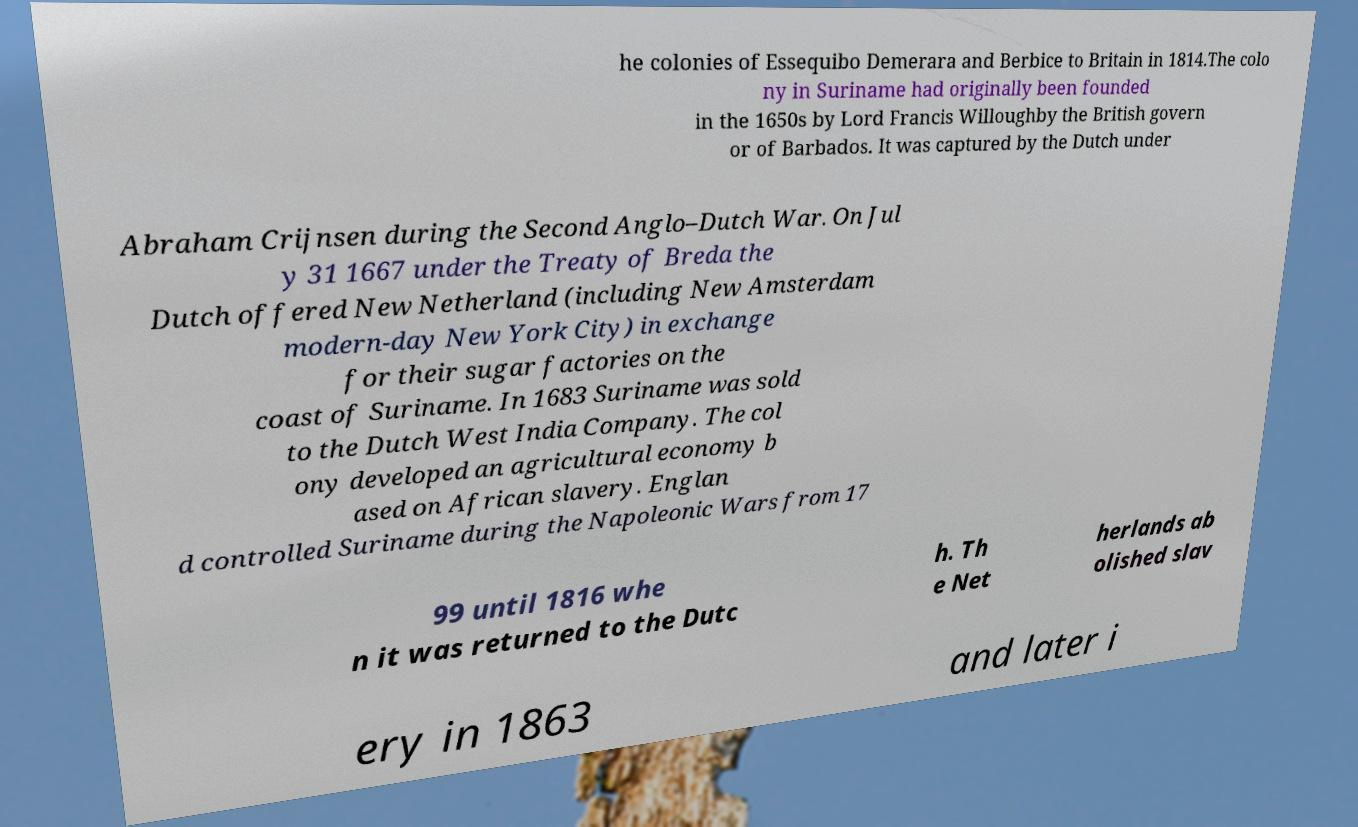I need the written content from this picture converted into text. Can you do that? he colonies of Essequibo Demerara and Berbice to Britain in 1814.The colo ny in Suriname had originally been founded in the 1650s by Lord Francis Willoughby the British govern or of Barbados. It was captured by the Dutch under Abraham Crijnsen during the Second Anglo–Dutch War. On Jul y 31 1667 under the Treaty of Breda the Dutch offered New Netherland (including New Amsterdam modern-day New York City) in exchange for their sugar factories on the coast of Suriname. In 1683 Suriname was sold to the Dutch West India Company. The col ony developed an agricultural economy b ased on African slavery. Englan d controlled Suriname during the Napoleonic Wars from 17 99 until 1816 whe n it was returned to the Dutc h. Th e Net herlands ab olished slav ery in 1863 and later i 